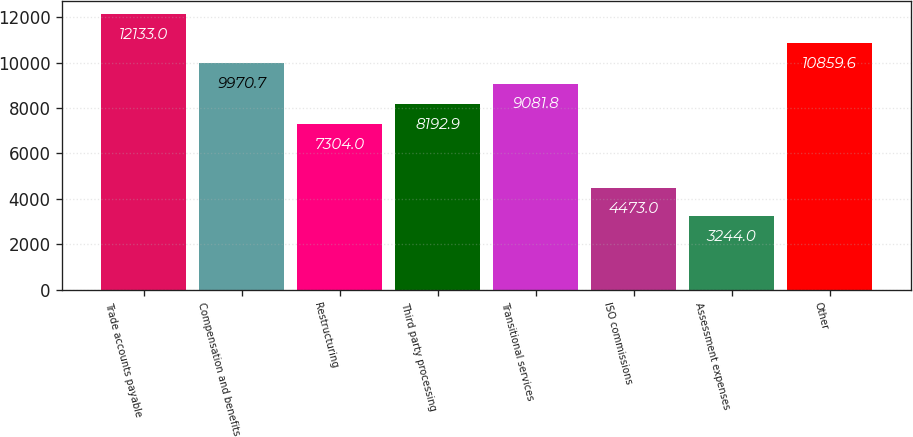<chart> <loc_0><loc_0><loc_500><loc_500><bar_chart><fcel>Trade accounts payable<fcel>Compensation and benefits<fcel>Restructuring<fcel>Third party processing<fcel>Transitional services<fcel>ISO commissions<fcel>Assessment expenses<fcel>Other<nl><fcel>12133<fcel>9970.7<fcel>7304<fcel>8192.9<fcel>9081.8<fcel>4473<fcel>3244<fcel>10859.6<nl></chart> 